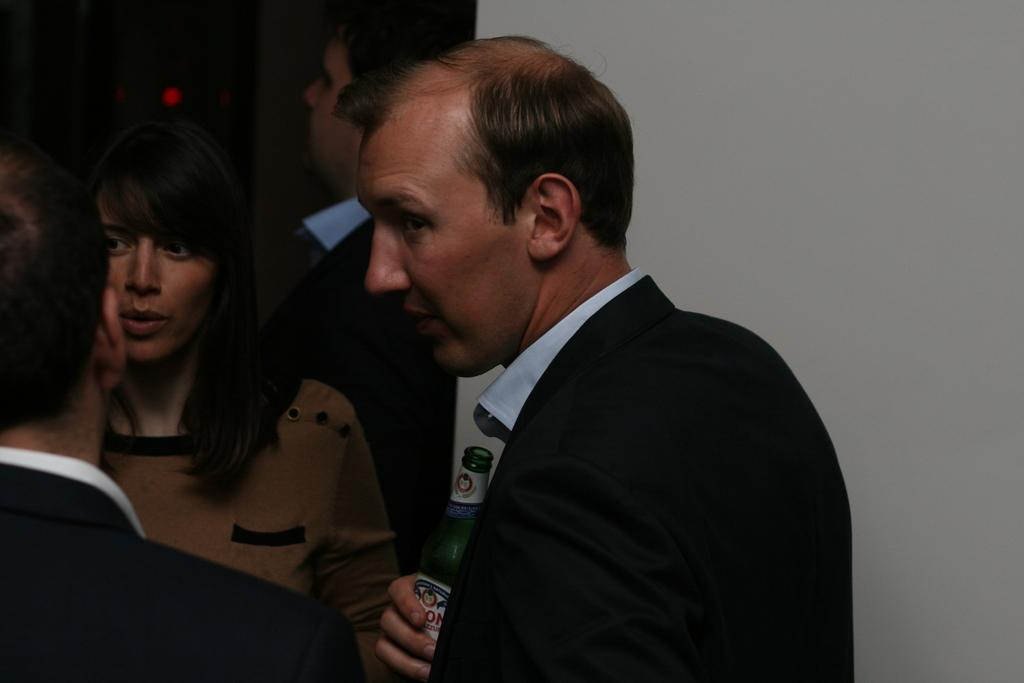What are the two people in the image doing? The man and the woman in the image are standing and talking. Can you describe the position of the man on the right side of the image? The man on the right side of the image is standing. What is the man on the right side of the image holding? The man on the right side of the image is holding a beer bottle. What type of bun is the man on the left side of the image eating? There is no man on the left side of the image, and no bun is visible in the image. Can you tell me how many plants are in the image? There are no plants present in the image. 